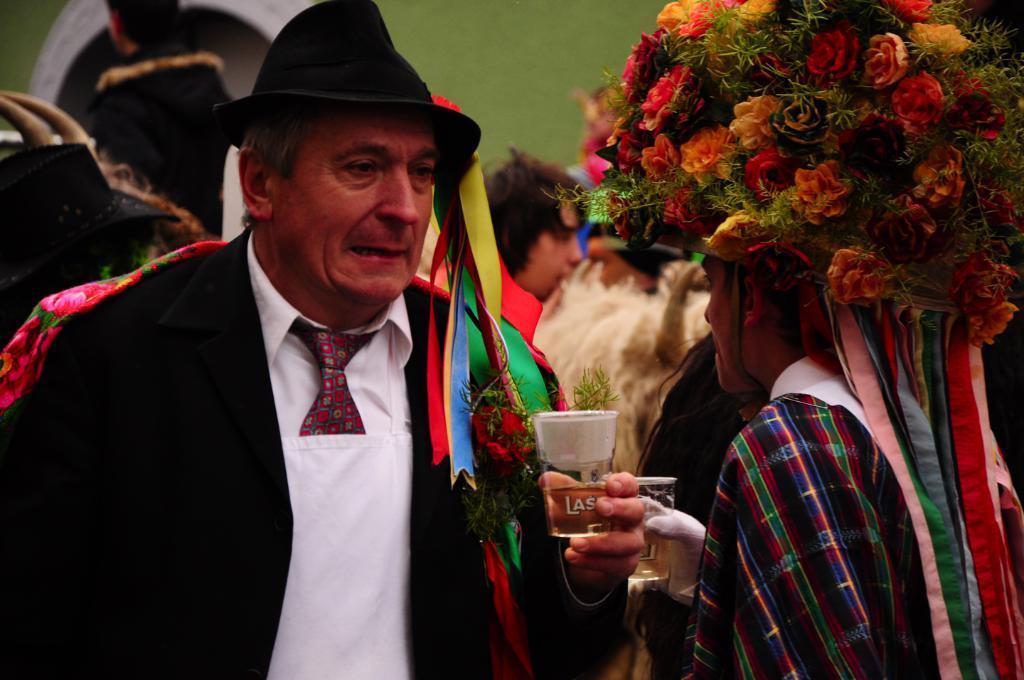Describe this image in one or two sentences. In this image we can see a group of people standing on the floor. One person wearing black coat and hat is holding a glass in his hand. One person wearing a helmet made of flowers and ribbons. In the background, we can see a person in a white coat. 